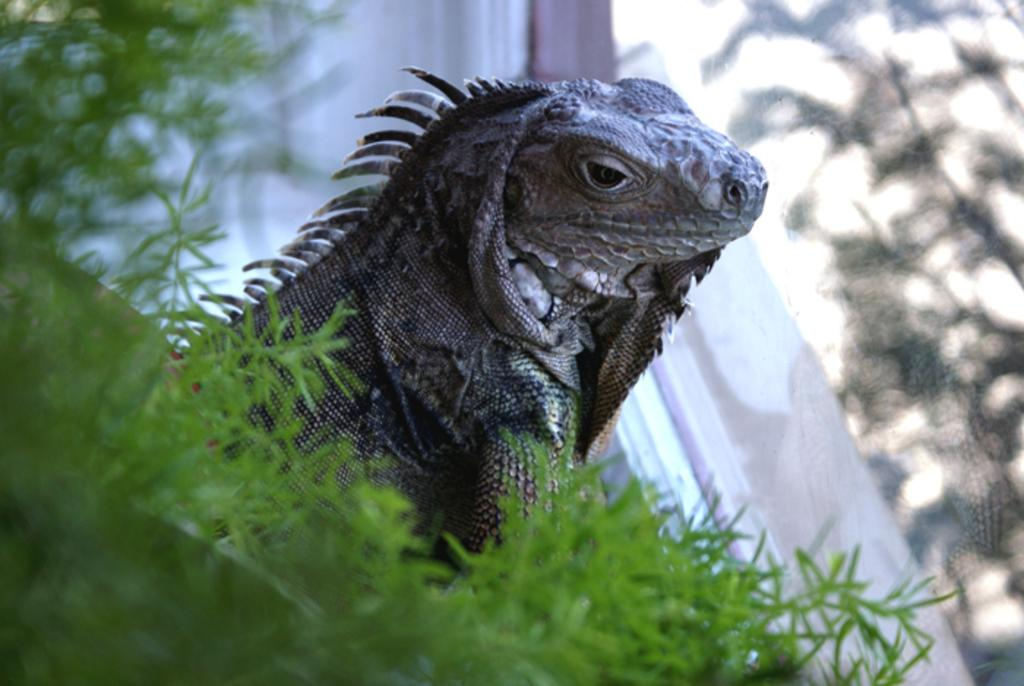What is the main subject in the foreground of the image? There is a plant in the foreground of the image. What can be seen behind the plant? There is a garden lizard behind the plant. Can you describe the object on the right side of the image? There appears to be a glass in the background on the right side of the image. How many goldfish are swimming in the plant in the image? There are no goldfish present in the image; it features a plant and a garden lizard. What type of trick can be performed with the glass in the background? There is no trick being performed with the glass in the background; it is simply an object in the image. 